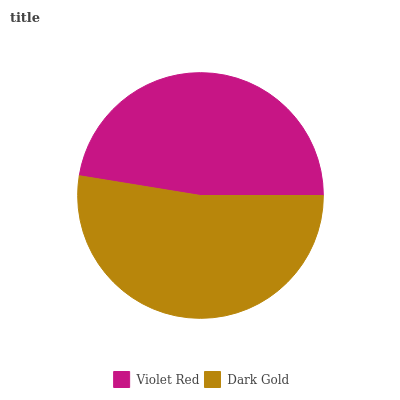Is Violet Red the minimum?
Answer yes or no. Yes. Is Dark Gold the maximum?
Answer yes or no. Yes. Is Dark Gold the minimum?
Answer yes or no. No. Is Dark Gold greater than Violet Red?
Answer yes or no. Yes. Is Violet Red less than Dark Gold?
Answer yes or no. Yes. Is Violet Red greater than Dark Gold?
Answer yes or no. No. Is Dark Gold less than Violet Red?
Answer yes or no. No. Is Dark Gold the high median?
Answer yes or no. Yes. Is Violet Red the low median?
Answer yes or no. Yes. Is Violet Red the high median?
Answer yes or no. No. Is Dark Gold the low median?
Answer yes or no. No. 